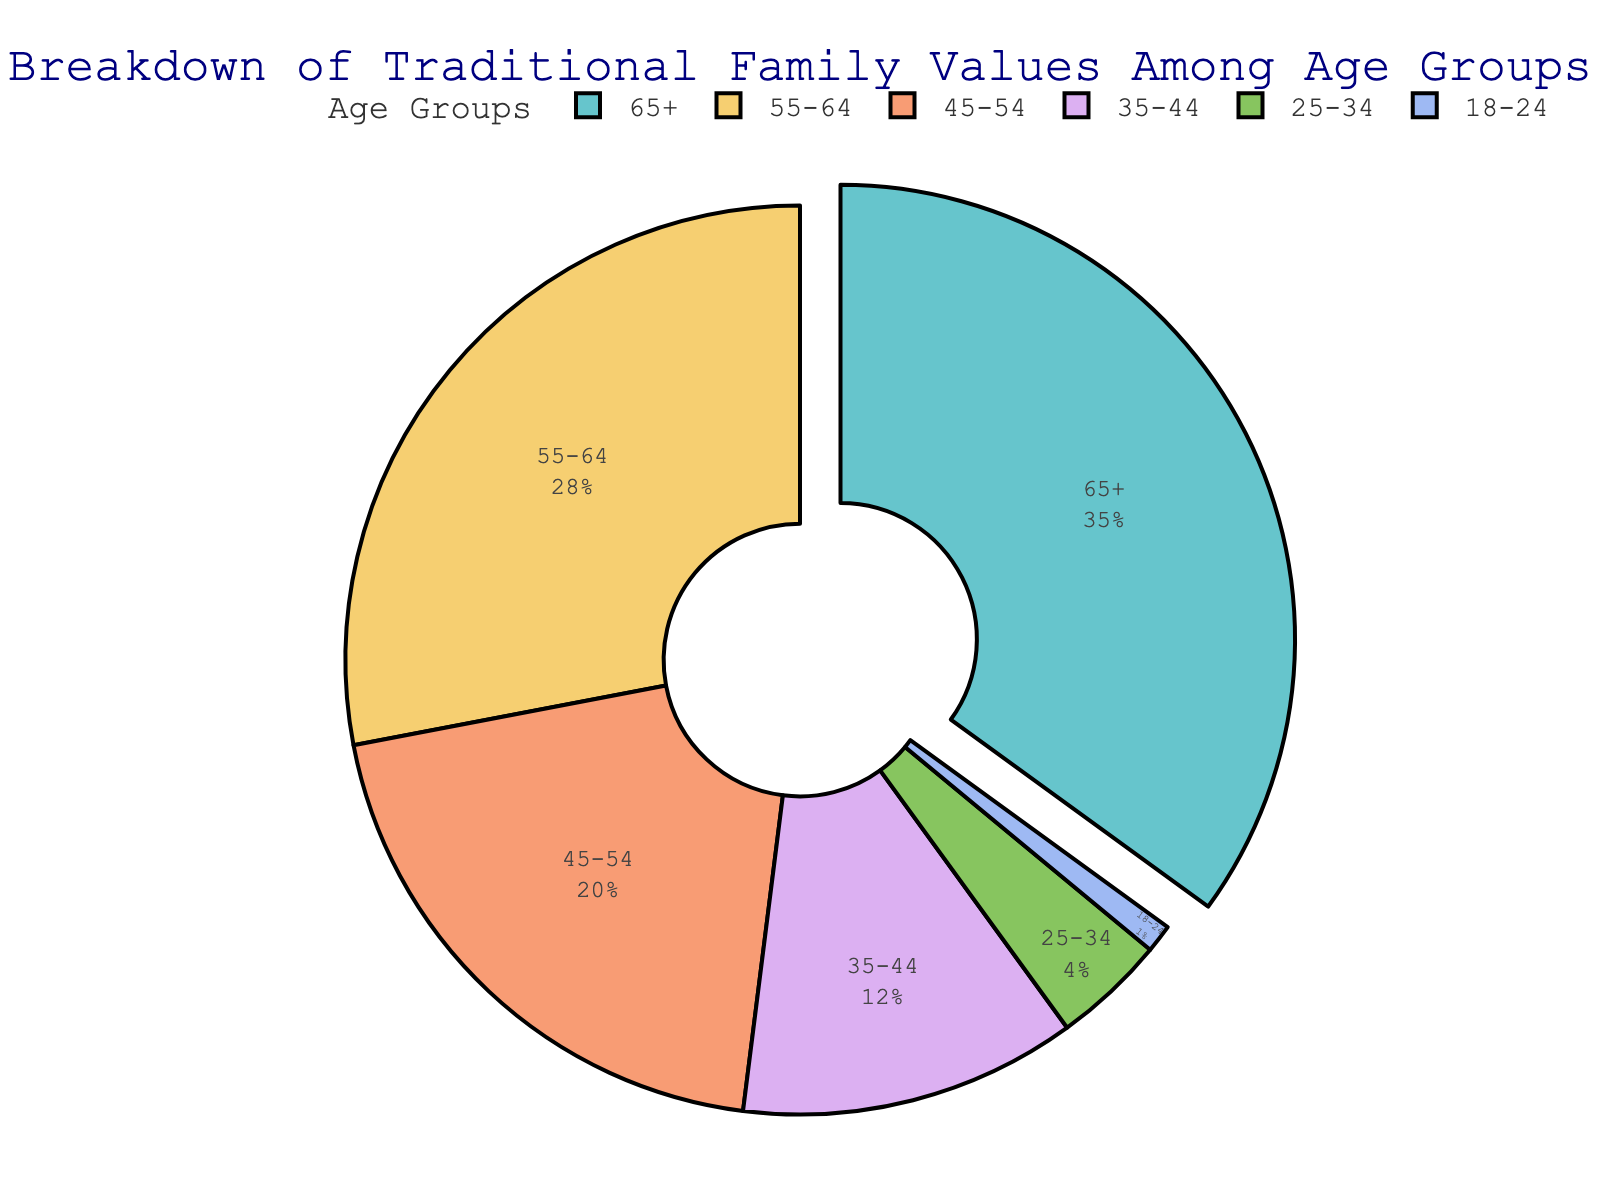What is the age group with the highest representation in traditional family values? The figure shows a pie chart with different age groups and their respective percentages. By identifying the largest section of the pie chart, we can determine that the age group 65+ has the highest representation.
Answer: 65+ How does the combined percentage of the age groups 55-64 and 45-54 compare to the 65+ age group? To compare these groups, sum the percentages of 55-64 (28%) and 45-54 (20%), which equals 48%. The percentage for 65+ is 35%. Therefore, 48% is greater than 35%.
Answer: 48% > 35% What is the total percentage represented by age groups under 35? Add the percentages of the age groups 35-44 (12%), 25-34 (4%), and 18-24 (1%). The total is 12% + 4% + 1% = 17%.
Answer: 17% Which age group has the smallest representation and what is its percentage? By looking at the smallest section of the pie chart, we see that the age group 18-24 has the smallest representation at 1%.
Answer: 18-24, 1% What is the difference in percentage between the age groups 45-54 and 35-44? Subtract the percentage of the 35-44 age group (12%) from the 45-54 age group (20%). The difference is 20% - 12% = 8%.
Answer: 8% What percentage of the population over 45 years old believe in traditional family values? Sum the percentages of the age groups 45-54 (20%), 55-64 (28%), and 65+ (35%). The total is 20% + 28% + 35% = 83%.
Answer: 83% How does the visual layout emphasize the importance of the age group 65+? The section representing the age group 65+ is visually "pulled" out from the pie chart, making it stand out from the other segments. This emphasizes its significance.
Answer: Pulled out segment Which two adjacent age groups combined have the highest representation? By examining the adjacent age groups, we see that the combination of 55-64 (28%) and 65+ (35%) has a total of 63%, which is the highest.
Answer: 55-64 and 65+ Is there a significant drop in representation among younger age groups (below 35)? Yes, the sum of percentages for age groups under 35 is 17% (12% for 35-44, 4% for 25-34, and 1% for 18-24). This is relatively low compared to older age groups, indicating a significant drop.
Answer: Yes What is the average percentage of the 45-54 and 55-64 age groups? To find the average, sum the percentages of the 45-54 (20%) and 55-64 (28%) age groups, which equals 48%. Then divide by 2, yielding an average of 24%.
Answer: 24% 